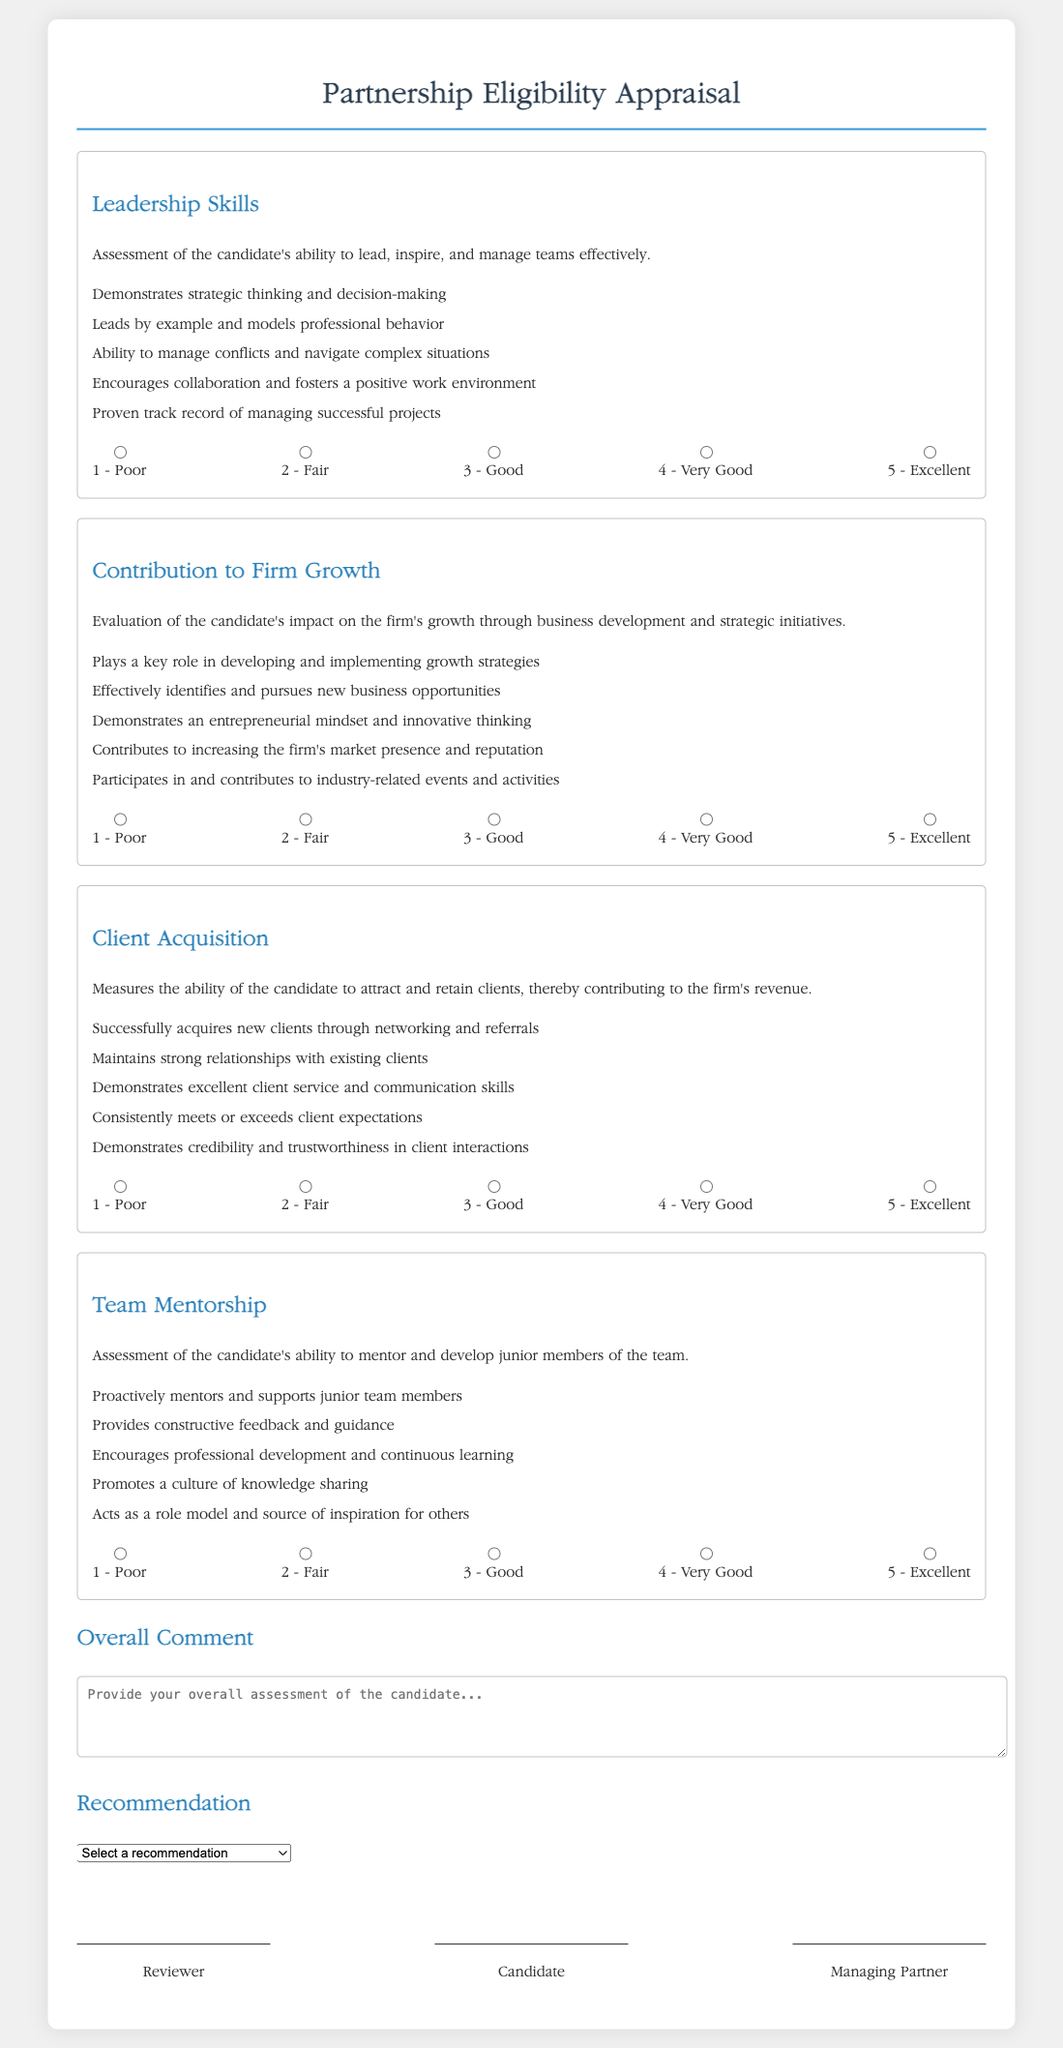What are the four main criteria assessed in the document? The document evaluates Leadership Skills, Contribution to Firm Growth, Client Acquisition, and Team Mentorship.
Answer: Leadership Skills, Contribution to Firm Growth, Client Acquisition, Team Mentorship What rating corresponds to "Very Good" in the Leadership Skills section? The rating scale provides a corresponding number for each descriptor; "Very Good" is rated as 4.
Answer: 4 How many indicators are listed under Client Acquisition? The document lists five indicators to assess Client Acquisition.
Answer: 5 What overall recommendation options are provided in the document? The document includes options such as Not Recommended, Recommended with Reservations, Recommended, and Highly Recommended.
Answer: Not Recommended, Recommended with Reservations, Recommended, Highly Recommended What role does the reviewer have in the approval process? The reviewer must provide their signature in the designated area, indicating their approval or feedback on the candidate's appraisal.
Answer: Signature of Reviewer Which section requires an overall assessment of the candidate? The "Overall Comment" section is specifically designated for providing an overall assessment of the candidate.
Answer: Overall Comment What is the rating for "Poor" in the Team Mentorship section? According to the rating scale, "Poor" corresponds to the value of 1.
Answer: 1 What does effective mentorship involve according to the Team Mentorship criteria? Effective mentorship involves providing constructive feedback and guidance to junior members of the team.
Answer: Providing constructive feedback and guidance 